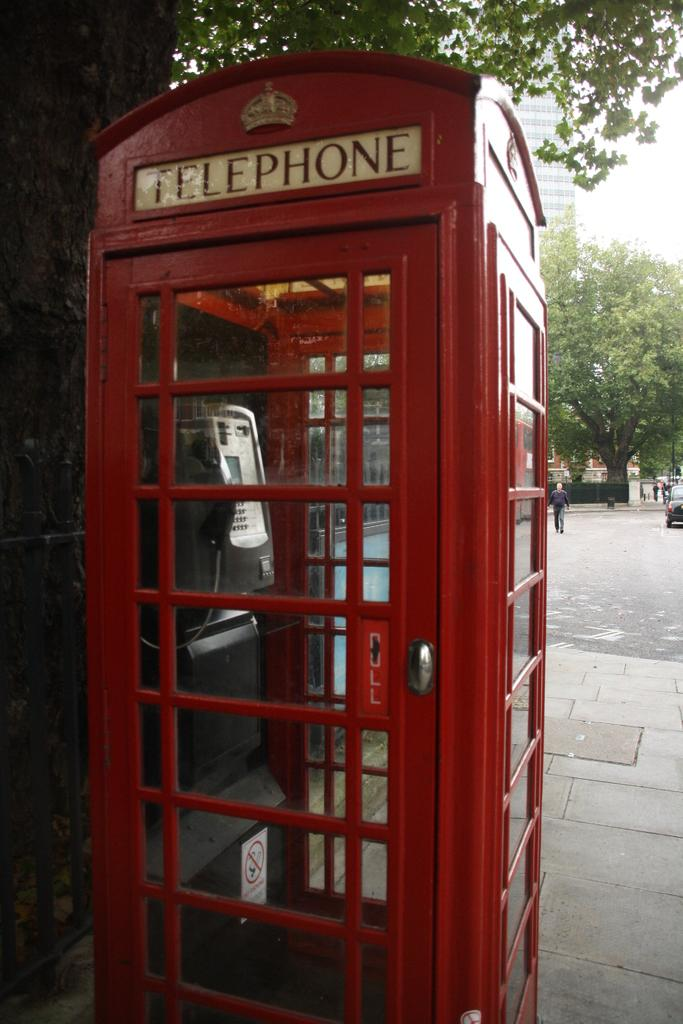<image>
Summarize the visual content of the image. A red telephone pay phone booth located on a city sidewalk. 